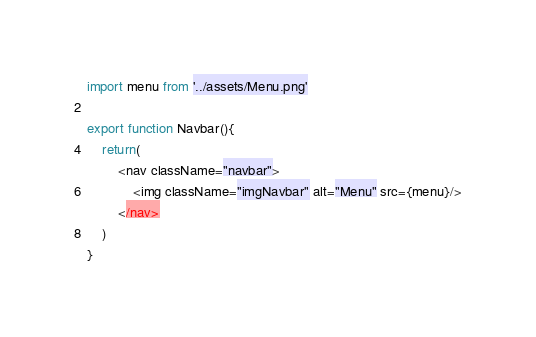Convert code to text. <code><loc_0><loc_0><loc_500><loc_500><_TypeScript_>import menu from '../assets/Menu.png'

export function Navbar(){
    return(
        <nav className="navbar">
            <img className="imgNavbar" alt="Menu" src={menu}/>
        </nav>
    )
} </code> 